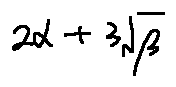Convert formula to latex. <formula><loc_0><loc_0><loc_500><loc_500>2 \alpha + 3 \sqrt { \beta }</formula> 